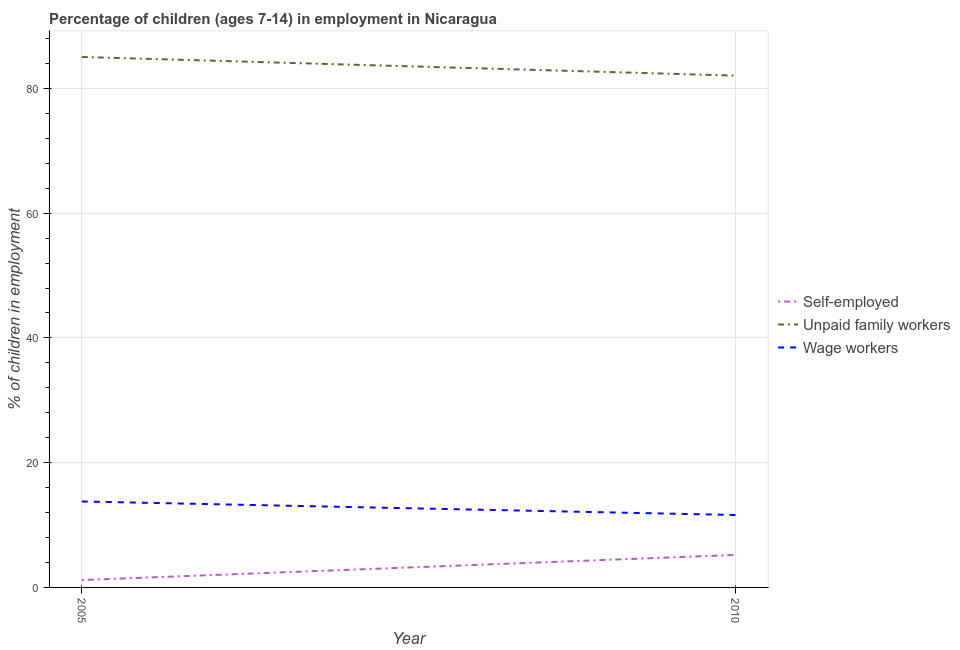What is the percentage of self employed children in 2005?
Your answer should be compact. 1.18. Across all years, what is the maximum percentage of children employed as wage workers?
Provide a succinct answer. 13.78. Across all years, what is the minimum percentage of self employed children?
Your answer should be very brief. 1.18. In which year was the percentage of children employed as wage workers minimum?
Make the answer very short. 2010. What is the total percentage of self employed children in the graph?
Provide a short and direct response. 6.39. What is the difference between the percentage of self employed children in 2005 and that in 2010?
Ensure brevity in your answer.  -4.03. What is the difference between the percentage of children employed as wage workers in 2010 and the percentage of children employed as unpaid family workers in 2005?
Provide a succinct answer. -73.43. What is the average percentage of self employed children per year?
Your response must be concise. 3.19. In the year 2010, what is the difference between the percentage of self employed children and percentage of children employed as unpaid family workers?
Make the answer very short. -76.84. What is the ratio of the percentage of self employed children in 2005 to that in 2010?
Keep it short and to the point. 0.23. Is the percentage of children employed as wage workers in 2005 less than that in 2010?
Your response must be concise. No. In how many years, is the percentage of children employed as wage workers greater than the average percentage of children employed as wage workers taken over all years?
Your response must be concise. 1. Is the percentage of children employed as unpaid family workers strictly greater than the percentage of self employed children over the years?
Offer a very short reply. Yes. Is the percentage of self employed children strictly less than the percentage of children employed as wage workers over the years?
Give a very brief answer. Yes. How many lines are there?
Give a very brief answer. 3. What is the difference between two consecutive major ticks on the Y-axis?
Give a very brief answer. 20. Are the values on the major ticks of Y-axis written in scientific E-notation?
Offer a very short reply. No. Does the graph contain any zero values?
Your response must be concise. No. Does the graph contain grids?
Provide a short and direct response. Yes. Where does the legend appear in the graph?
Your response must be concise. Center right. What is the title of the graph?
Offer a very short reply. Percentage of children (ages 7-14) in employment in Nicaragua. Does "Coal" appear as one of the legend labels in the graph?
Ensure brevity in your answer.  No. What is the label or title of the Y-axis?
Keep it short and to the point. % of children in employment. What is the % of children in employment of Self-employed in 2005?
Provide a short and direct response. 1.18. What is the % of children in employment of Unpaid family workers in 2005?
Keep it short and to the point. 85.04. What is the % of children in employment of Wage workers in 2005?
Provide a short and direct response. 13.78. What is the % of children in employment of Self-employed in 2010?
Your answer should be very brief. 5.21. What is the % of children in employment of Unpaid family workers in 2010?
Provide a short and direct response. 82.05. What is the % of children in employment in Wage workers in 2010?
Offer a terse response. 11.61. Across all years, what is the maximum % of children in employment of Self-employed?
Your answer should be compact. 5.21. Across all years, what is the maximum % of children in employment in Unpaid family workers?
Offer a terse response. 85.04. Across all years, what is the maximum % of children in employment of Wage workers?
Offer a very short reply. 13.78. Across all years, what is the minimum % of children in employment in Self-employed?
Provide a succinct answer. 1.18. Across all years, what is the minimum % of children in employment in Unpaid family workers?
Keep it short and to the point. 82.05. Across all years, what is the minimum % of children in employment of Wage workers?
Make the answer very short. 11.61. What is the total % of children in employment in Self-employed in the graph?
Make the answer very short. 6.39. What is the total % of children in employment of Unpaid family workers in the graph?
Provide a short and direct response. 167.09. What is the total % of children in employment in Wage workers in the graph?
Your response must be concise. 25.39. What is the difference between the % of children in employment of Self-employed in 2005 and that in 2010?
Make the answer very short. -4.03. What is the difference between the % of children in employment of Unpaid family workers in 2005 and that in 2010?
Your response must be concise. 2.99. What is the difference between the % of children in employment in Wage workers in 2005 and that in 2010?
Your answer should be compact. 2.17. What is the difference between the % of children in employment in Self-employed in 2005 and the % of children in employment in Unpaid family workers in 2010?
Give a very brief answer. -80.87. What is the difference between the % of children in employment of Self-employed in 2005 and the % of children in employment of Wage workers in 2010?
Provide a short and direct response. -10.43. What is the difference between the % of children in employment in Unpaid family workers in 2005 and the % of children in employment in Wage workers in 2010?
Offer a very short reply. 73.43. What is the average % of children in employment in Self-employed per year?
Offer a very short reply. 3.19. What is the average % of children in employment of Unpaid family workers per year?
Keep it short and to the point. 83.55. What is the average % of children in employment in Wage workers per year?
Offer a very short reply. 12.7. In the year 2005, what is the difference between the % of children in employment in Self-employed and % of children in employment in Unpaid family workers?
Give a very brief answer. -83.86. In the year 2005, what is the difference between the % of children in employment of Unpaid family workers and % of children in employment of Wage workers?
Ensure brevity in your answer.  71.26. In the year 2010, what is the difference between the % of children in employment of Self-employed and % of children in employment of Unpaid family workers?
Your response must be concise. -76.84. In the year 2010, what is the difference between the % of children in employment of Self-employed and % of children in employment of Wage workers?
Your answer should be compact. -6.4. In the year 2010, what is the difference between the % of children in employment of Unpaid family workers and % of children in employment of Wage workers?
Offer a terse response. 70.44. What is the ratio of the % of children in employment of Self-employed in 2005 to that in 2010?
Make the answer very short. 0.23. What is the ratio of the % of children in employment in Unpaid family workers in 2005 to that in 2010?
Your response must be concise. 1.04. What is the ratio of the % of children in employment of Wage workers in 2005 to that in 2010?
Offer a terse response. 1.19. What is the difference between the highest and the second highest % of children in employment of Self-employed?
Provide a short and direct response. 4.03. What is the difference between the highest and the second highest % of children in employment of Unpaid family workers?
Provide a short and direct response. 2.99. What is the difference between the highest and the second highest % of children in employment in Wage workers?
Offer a terse response. 2.17. What is the difference between the highest and the lowest % of children in employment in Self-employed?
Your answer should be very brief. 4.03. What is the difference between the highest and the lowest % of children in employment of Unpaid family workers?
Your answer should be compact. 2.99. What is the difference between the highest and the lowest % of children in employment in Wage workers?
Provide a succinct answer. 2.17. 